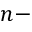Convert formula to latex. <formula><loc_0><loc_0><loc_500><loc_500>n -</formula> 